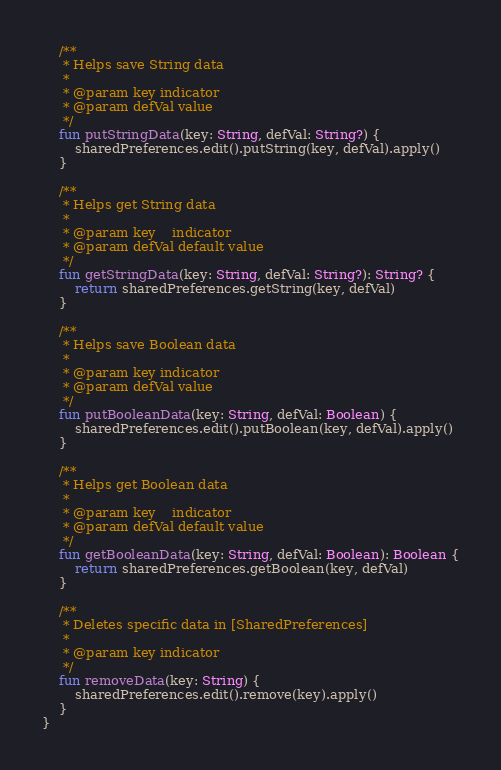Convert code to text. <code><loc_0><loc_0><loc_500><loc_500><_Kotlin_>    /**
     * Helps save String data
     *
     * @param key indicator
     * @param defVal value
     */
    fun putStringData(key: String, defVal: String?) {
        sharedPreferences.edit().putString(key, defVal).apply()
    }

    /**
     * Helps get String data
     *
     * @param key    indicator
     * @param defVal default value
     */
    fun getStringData(key: String, defVal: String?): String? {
        return sharedPreferences.getString(key, defVal)
    }

    /**
     * Helps save Boolean data
     *
     * @param key indicator
     * @param defVal value
     */
    fun putBooleanData(key: String, defVal: Boolean) {
        sharedPreferences.edit().putBoolean(key, defVal).apply()
    }

    /**
     * Helps get Boolean data
     *
     * @param key    indicator
     * @param defVal default value
     */
    fun getBooleanData(key: String, defVal: Boolean): Boolean {
        return sharedPreferences.getBoolean(key, defVal)
    }

    /**
     * Deletes specific data in [SharedPreferences]
     *
     * @param key indicator
     */
    fun removeData(key: String) {
        sharedPreferences.edit().remove(key).apply()
    }
}
</code> 